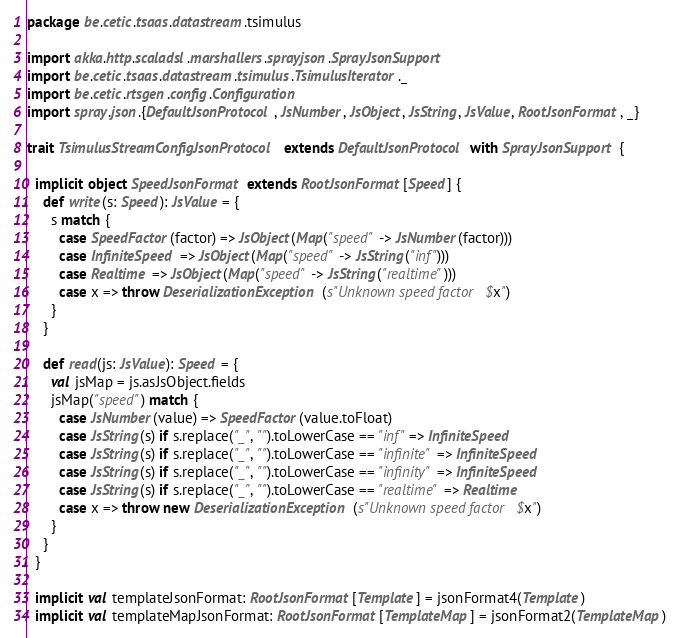<code> <loc_0><loc_0><loc_500><loc_500><_Scala_>package be.cetic.tsaas.datastream.tsimulus

import akka.http.scaladsl.marshallers.sprayjson.SprayJsonSupport
import be.cetic.tsaas.datastream.tsimulus.TsimulusIterator._
import be.cetic.rtsgen.config.Configuration
import spray.json.{DefaultJsonProtocol, JsNumber, JsObject, JsString, JsValue, RootJsonFormat, _}

trait TsimulusStreamConfigJsonProtocol extends DefaultJsonProtocol with SprayJsonSupport {

  implicit object SpeedJsonFormat extends RootJsonFormat[Speed] {
    def write(s: Speed): JsValue = {
      s match {
        case SpeedFactor(factor) => JsObject(Map("speed" -> JsNumber(factor)))
        case InfiniteSpeed => JsObject(Map("speed" -> JsString("inf")))
        case Realtime => JsObject(Map("speed" -> JsString("realtime")))
        case x => throw DeserializationException(s"Unknown speed factor $x")
      }
    }

    def read(js: JsValue): Speed = {
      val jsMap = js.asJsObject.fields
      jsMap("speed") match {
        case JsNumber(value) => SpeedFactor(value.toFloat)
        case JsString(s) if s.replace("_", "").toLowerCase == "inf" => InfiniteSpeed
        case JsString(s) if s.replace("_", "").toLowerCase == "infinite" => InfiniteSpeed
        case JsString(s) if s.replace("_", "").toLowerCase == "infinity" => InfiniteSpeed
        case JsString(s) if s.replace("_", "").toLowerCase == "realtime" => Realtime
        case x => throw new DeserializationException(s"Unknown speed factor $x")
      }
    }
  }

  implicit val templateJsonFormat: RootJsonFormat[Template] = jsonFormat4(Template)
  implicit val templateMapJsonFormat: RootJsonFormat[TemplateMap] = jsonFormat2(TemplateMap)
</code> 